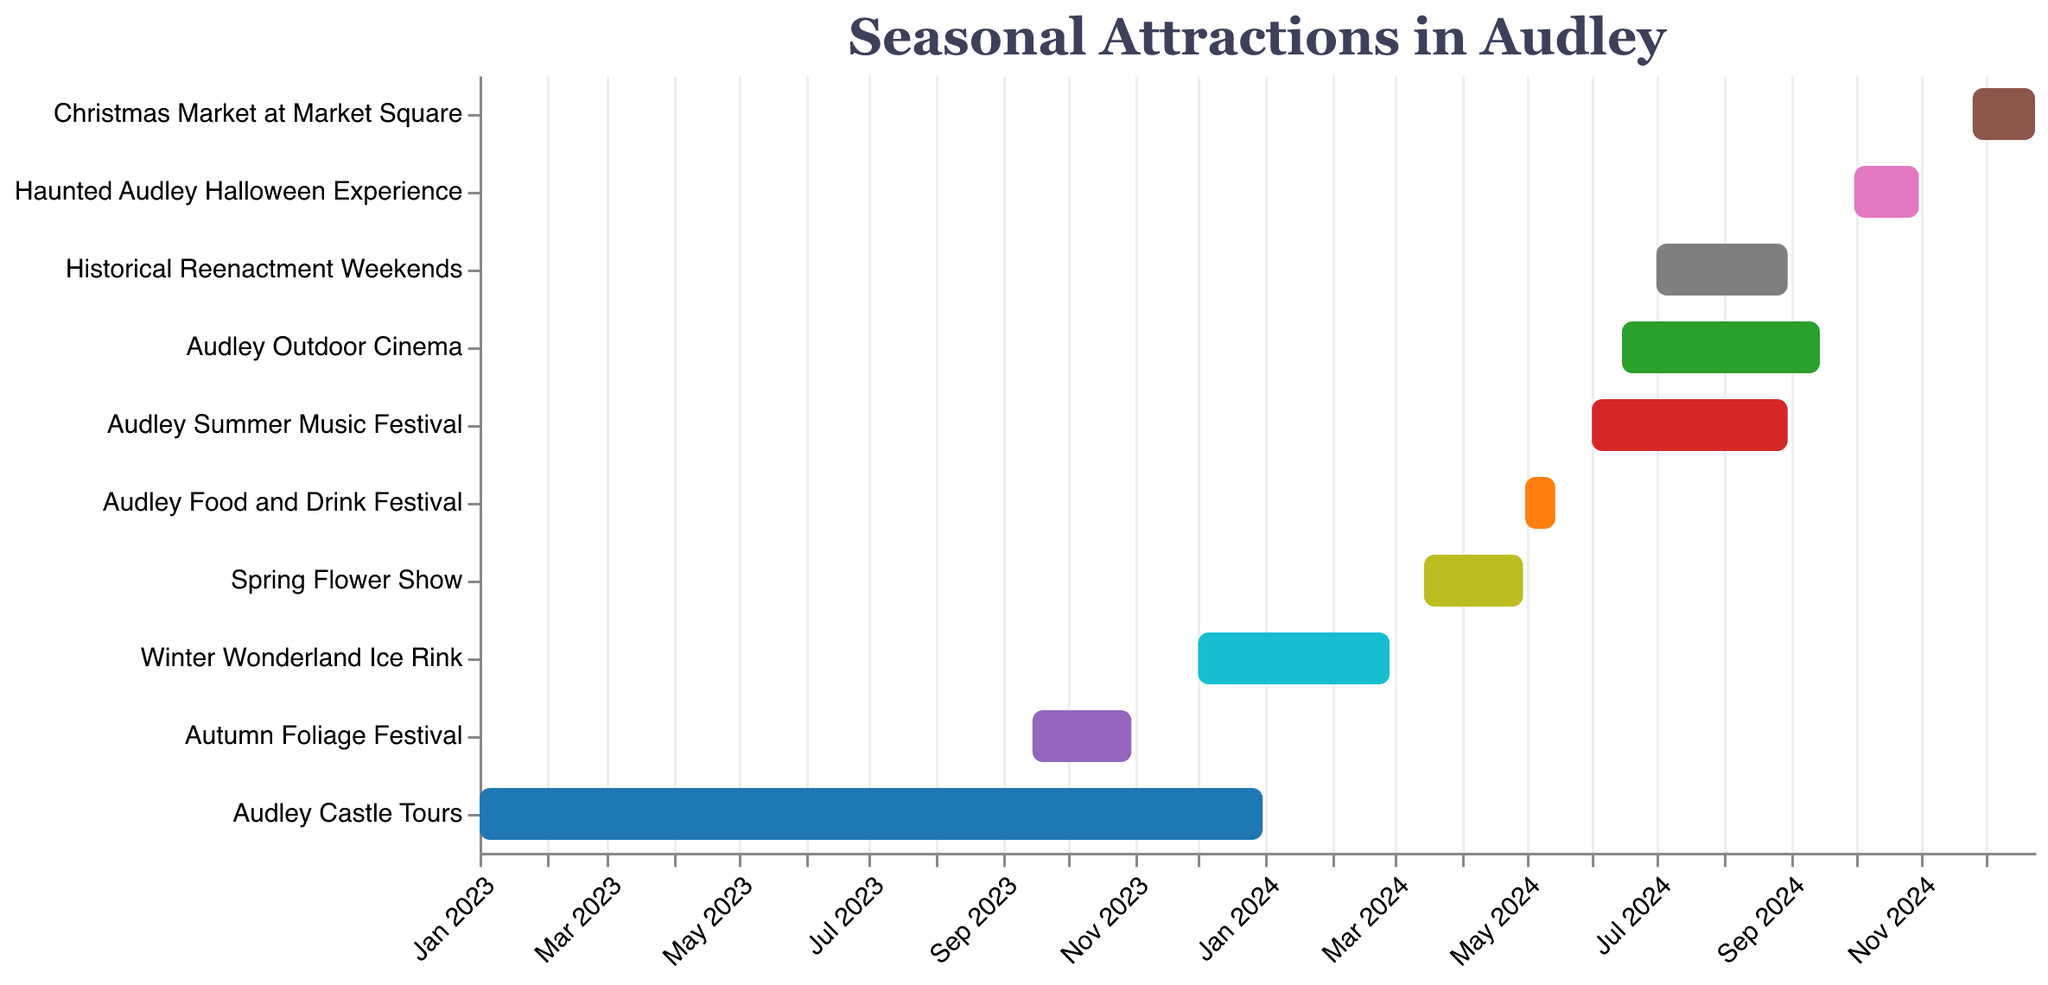What's the duration of the Winter Wonderland Ice Rink event? The Winter Wonderland Ice Rink starts on December 1, 2023, and ends on February 28, 2024. To find the duration, count all the days from the start to the end, inclusive. December has 31 days, January 2024 has 31 days, and February 2024 has 28 days. Summing these up gives 31 + 31 + 28 = 90 days.
Answer: 90 days Which attraction lasts the longest? To determine which attraction lasts the longest, check the start and end dates for each attraction and calculate the duration. Audley Castle Tours runs from January 1, 2023, to December 31, 2023, making it a year-long event. This is the longest duration among the attractions.
Answer: Audley Castle Tours How many attractions are available in August 2024? To find the number of attractions available in August 2024, look at all attractions that overlap with August 2024. The attractions are: Audley Summer Music Festival (June 1 - August 31, 2024), Historical Reenactment Weekends (July 1 - August 31, 2024), and Audley Outdoor Cinema (June 15 - September 15, 2024).
Answer: 3 Does the Audley Food and Drink Festival overlap with the Spring Flower Show? The Audley Food and Drink Festival runs from May 1 to May 15, 2024, and the Spring Flower Show runs from March 15 to April 30, 2024. Since the Spring Flower Show ends on April 30 and the Food and Drink Festival starts on May 1, there is no overlap.
Answer: No Which two attractions span the shortest timeframe? To find the two shortest events, compare the duration of each attraction. The Haunted Audley Halloween Experience runs from October 1 to October 31, 2024, lasting 31 days. The Audley Food and Drink Festival runs from May 1 to May 15, 2024, lasting 15 days. These are the two shortest events.
Answer: Haunted Audley Halloween Experience and Audley Food and Drink Festival What month has the most overlapping attractions? To determine the month with the most overlapping attractions, identify in which months the attractions occur and count them. July 2024 has the following attractions: Audley Summer Music Festival, Historical Reenactment Weekends, and Audley Outdoor Cinema. This makes it the month with the most activities.
Answer: July 2024 Is the Christmas Market at Market Square fully in 2024? The Christmas Market at Market Square runs from November 25 to December 24, 2024. Both the start and end dates fall within the year 2024.
Answer: Yes What season has the most events in Audley? Seasons can be classified as: Winter (Dec-Feb), Spring (Mar-May), Summer (Jun-Aug), and Autumn (Sep-Nov). Counting events in these ranges: Winter has 2 (Winter Wonderland Ice Rink, Christmas Market), Spring has 2 (Spring Flower Show, Audley Food and Drink Festival), Summer has 3 (Audley Summer Music Festival, Historical Reenactment Weekends, Audley Outdoor Cinema), and Autumn has 2 (Autumn Foliage Festival, Haunted Audley Halloween Experience).
Answer: Summer 